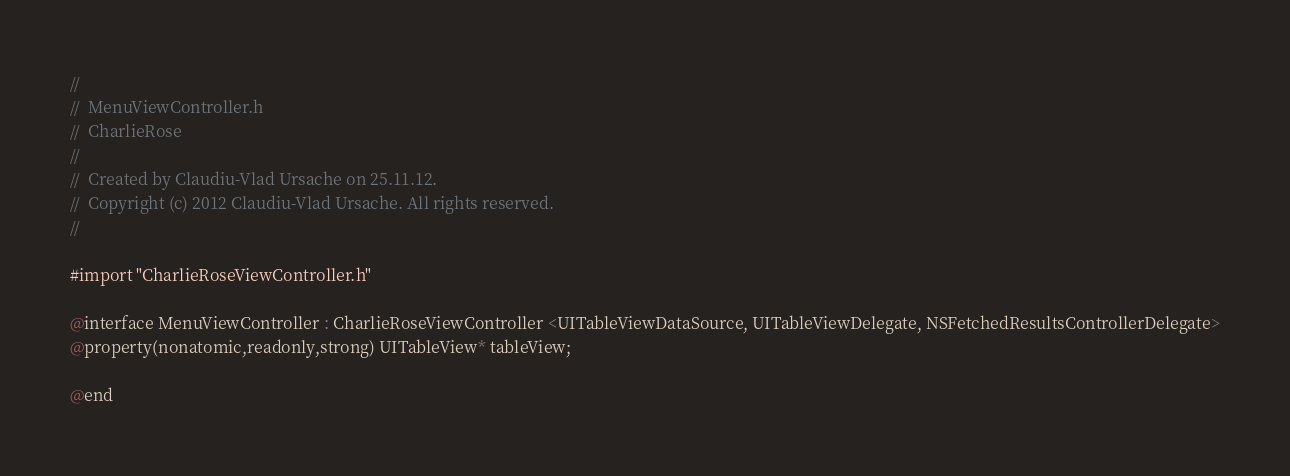<code> <loc_0><loc_0><loc_500><loc_500><_C_>//
//  MenuViewController.h
//  CharlieRose
//
//  Created by Claudiu-Vlad Ursache on 25.11.12.
//  Copyright (c) 2012 Claudiu-Vlad Ursache. All rights reserved.
//

#import "CharlieRoseViewController.h"

@interface MenuViewController : CharlieRoseViewController <UITableViewDataSource, UITableViewDelegate, NSFetchedResultsControllerDelegate>
@property(nonatomic,readonly,strong) UITableView* tableView;

@end
</code> 